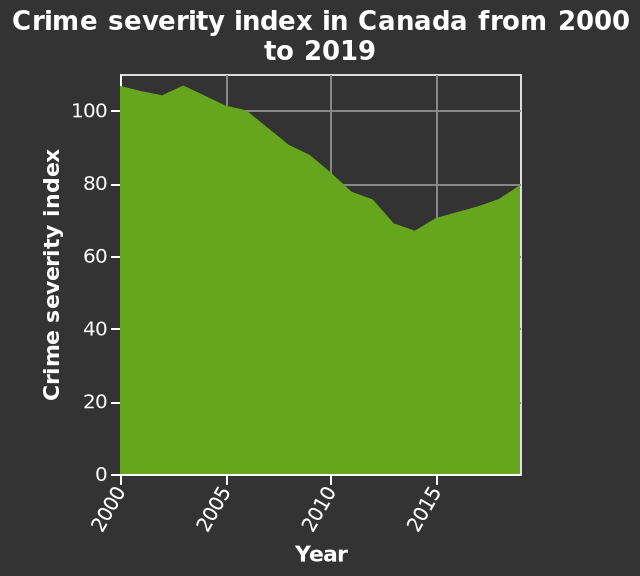<image>
Offer a thorough analysis of the image. Crime severity was highest in 2003.  Crime severity was the lowest in 2014. Describe the following image in detail This is a area diagram titled Crime severity index in Canada from 2000 to 2019. The y-axis measures Crime severity index while the x-axis shows Year. 